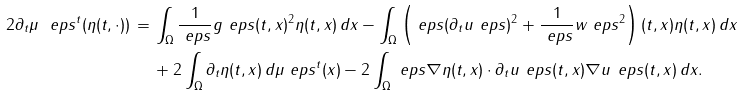Convert formula to latex. <formula><loc_0><loc_0><loc_500><loc_500>2 \partial _ { t } \mu _ { \ } e p s ^ { t } ( \eta ( t , \cdot ) ) \, = \, & \int _ { \Omega } \frac { 1 } { \ e p s } g _ { \ } e p s ( t , x ) ^ { 2 } \eta ( t , x ) \, d x - \int _ { \Omega } \left ( \ e p s ( \partial _ { t } u _ { \ } e p s ) ^ { 2 } + \frac { 1 } { \ e p s } w _ { \ } e p s ^ { 2 } \right ) ( t , x ) \eta ( t , x ) \, d x \\ & + 2 \int _ { \Omega } \partial _ { t } \eta ( t , x ) \, d \mu _ { \ } e p s ^ { t } ( x ) - 2 \int _ { \Omega } \ e p s \nabla \eta ( t , x ) \cdot \partial _ { t } u _ { \ } e p s ( t , x ) \nabla u _ { \ } e p s ( t , x ) \, d x .</formula> 